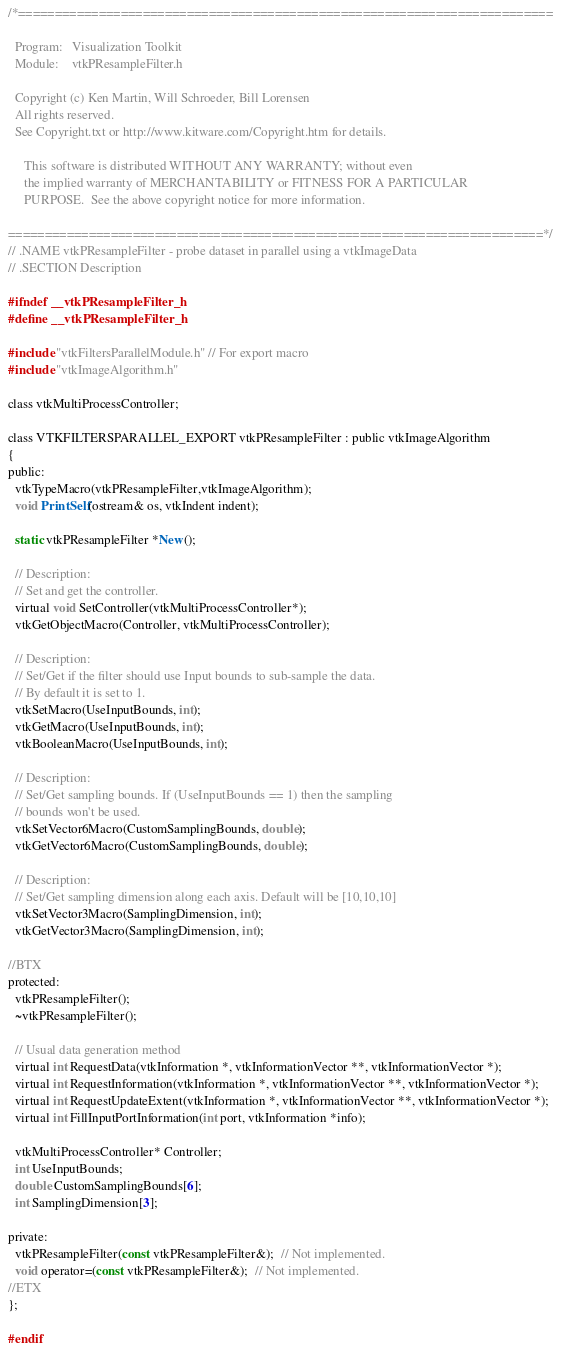<code> <loc_0><loc_0><loc_500><loc_500><_C_>/*=========================================================================

  Program:   Visualization Toolkit
  Module:    vtkPResampleFilter.h

  Copyright (c) Ken Martin, Will Schroeder, Bill Lorensen
  All rights reserved.
  See Copyright.txt or http://www.kitware.com/Copyright.htm for details.

     This software is distributed WITHOUT ANY WARRANTY; without even
     the implied warranty of MERCHANTABILITY or FITNESS FOR A PARTICULAR
     PURPOSE.  See the above copyright notice for more information.

=========================================================================*/
// .NAME vtkPResampleFilter - probe dataset in parallel using a vtkImageData
// .SECTION Description

#ifndef __vtkPResampleFilter_h
#define __vtkPResampleFilter_h

#include "vtkFiltersParallelModule.h" // For export macro
#include "vtkImageAlgorithm.h"

class vtkMultiProcessController;

class VTKFILTERSPARALLEL_EXPORT vtkPResampleFilter : public vtkImageAlgorithm
{
public:
  vtkTypeMacro(vtkPResampleFilter,vtkImageAlgorithm);
  void PrintSelf(ostream& os, vtkIndent indent);

  static vtkPResampleFilter *New();

  // Description:
  // Set and get the controller.
  virtual void SetController(vtkMultiProcessController*);
  vtkGetObjectMacro(Controller, vtkMultiProcessController);

  // Description:
  // Set/Get if the filter should use Input bounds to sub-sample the data.
  // By default it is set to 1.
  vtkSetMacro(UseInputBounds, int);
  vtkGetMacro(UseInputBounds, int);
  vtkBooleanMacro(UseInputBounds, int);

  // Description:
  // Set/Get sampling bounds. If (UseInputBounds == 1) then the sampling
  // bounds won't be used.
  vtkSetVector6Macro(CustomSamplingBounds, double);
  vtkGetVector6Macro(CustomSamplingBounds, double);

  // Description:
  // Set/Get sampling dimension along each axis. Default will be [10,10,10]
  vtkSetVector3Macro(SamplingDimension, int);
  vtkGetVector3Macro(SamplingDimension, int);

//BTX
protected:
  vtkPResampleFilter();
  ~vtkPResampleFilter();

  // Usual data generation method
  virtual int RequestData(vtkInformation *, vtkInformationVector **, vtkInformationVector *);
  virtual int RequestInformation(vtkInformation *, vtkInformationVector **, vtkInformationVector *);
  virtual int RequestUpdateExtent(vtkInformation *, vtkInformationVector **, vtkInformationVector *);
  virtual int FillInputPortInformation(int port, vtkInformation *info);

  vtkMultiProcessController* Controller;
  int UseInputBounds;
  double CustomSamplingBounds[6];
  int SamplingDimension[3];

private:
  vtkPResampleFilter(const vtkPResampleFilter&);  // Not implemented.
  void operator=(const vtkPResampleFilter&);  // Not implemented.
//ETX
};

#endif
</code> 